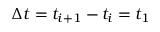<formula> <loc_0><loc_0><loc_500><loc_500>\Delta t = t _ { i + 1 } - t _ { i } = t _ { 1 }</formula> 